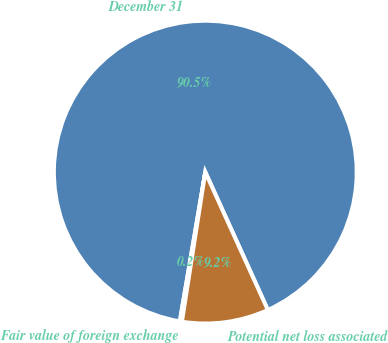Convert chart. <chart><loc_0><loc_0><loc_500><loc_500><pie_chart><fcel>December 31<fcel>Fair value of foreign exchange<fcel>Potential net loss associated<nl><fcel>90.54%<fcel>0.22%<fcel>9.25%<nl></chart> 